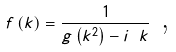Convert formula to latex. <formula><loc_0><loc_0><loc_500><loc_500>f \left ( k \right ) = \frac { 1 } { g \left ( k ^ { 2 } \right ) - i \text { } k } \text { ,}</formula> 